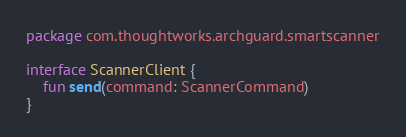<code> <loc_0><loc_0><loc_500><loc_500><_Kotlin_>package com.thoughtworks.archguard.smartscanner

interface ScannerClient {
    fun send(command: ScannerCommand)
}
</code> 